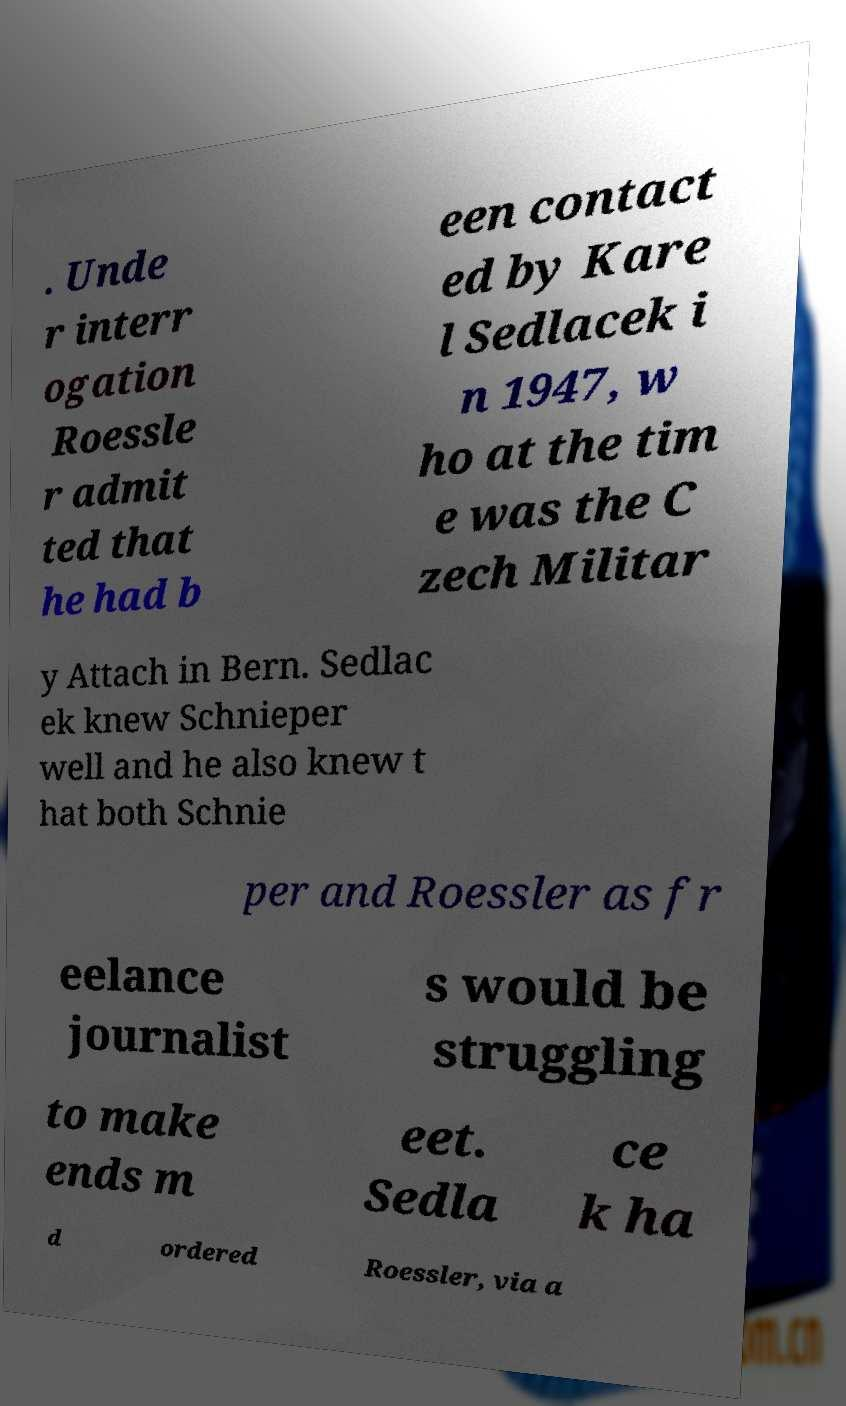Could you extract and type out the text from this image? . Unde r interr ogation Roessle r admit ted that he had b een contact ed by Kare l Sedlacek i n 1947, w ho at the tim e was the C zech Militar y Attach in Bern. Sedlac ek knew Schnieper well and he also knew t hat both Schnie per and Roessler as fr eelance journalist s would be struggling to make ends m eet. Sedla ce k ha d ordered Roessler, via a 